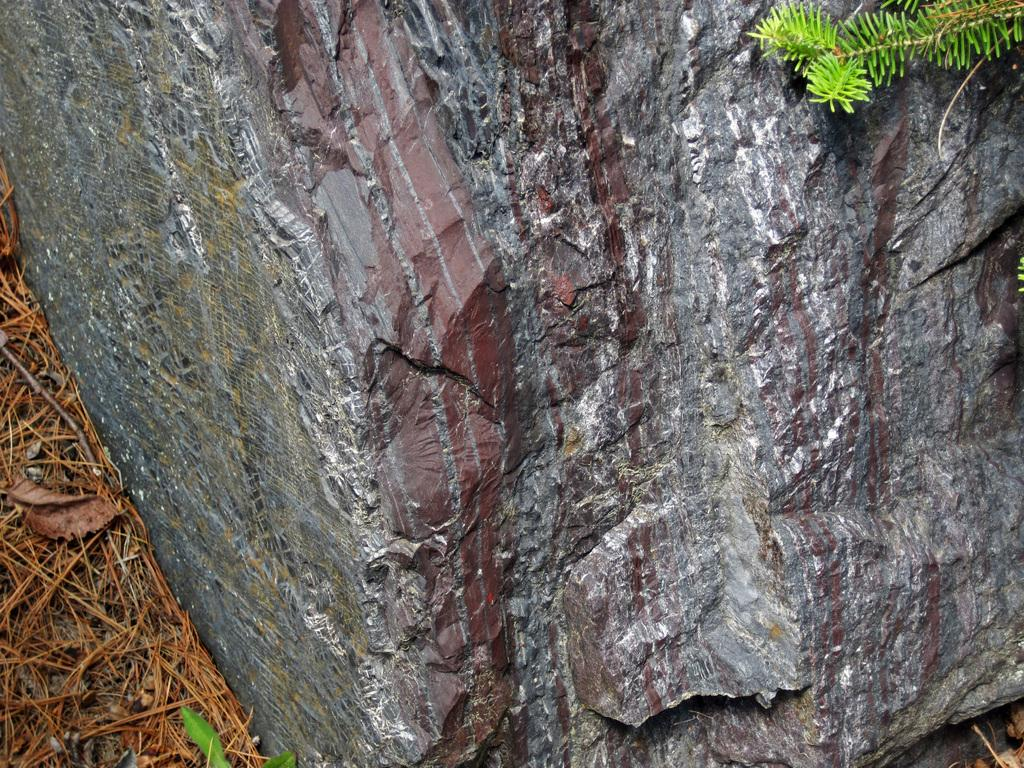What type of natural object can be seen in the image? There is a rock in the image. What type of vegetation is present in the image? There is dried grass and green leaves in the image. What type of leather can be seen in the image? There is no leather present in the image; it features a rock and vegetation. 